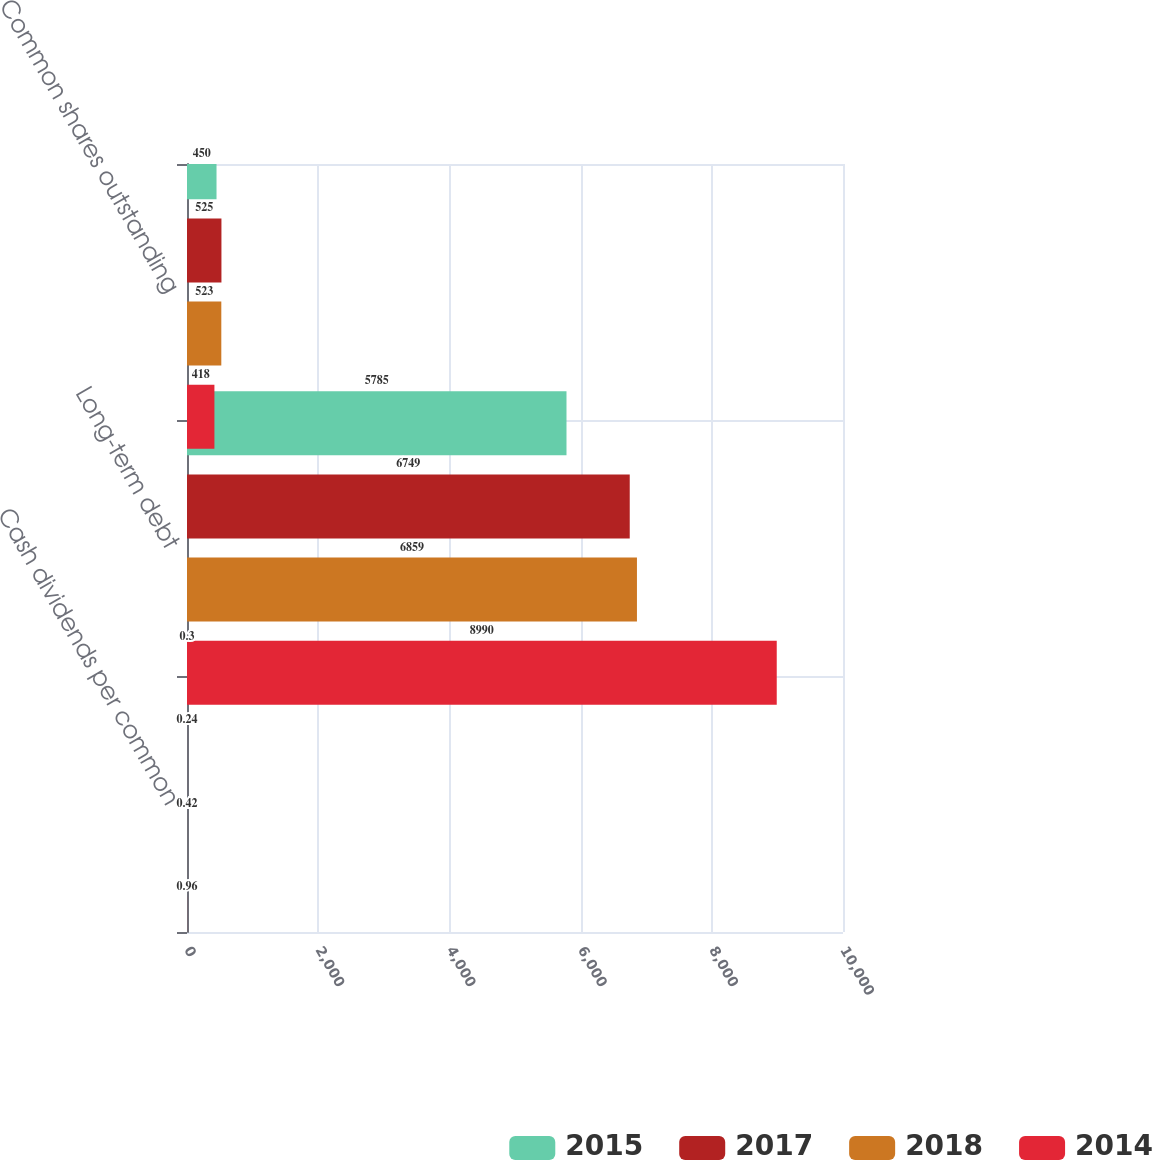Convert chart. <chart><loc_0><loc_0><loc_500><loc_500><stacked_bar_chart><ecel><fcel>Cash dividends per common<fcel>Long-term debt<fcel>Common shares outstanding<nl><fcel>2015<fcel>0.3<fcel>5785<fcel>450<nl><fcel>2017<fcel>0.24<fcel>6749<fcel>525<nl><fcel>2018<fcel>0.42<fcel>6859<fcel>523<nl><fcel>2014<fcel>0.96<fcel>8990<fcel>418<nl></chart> 